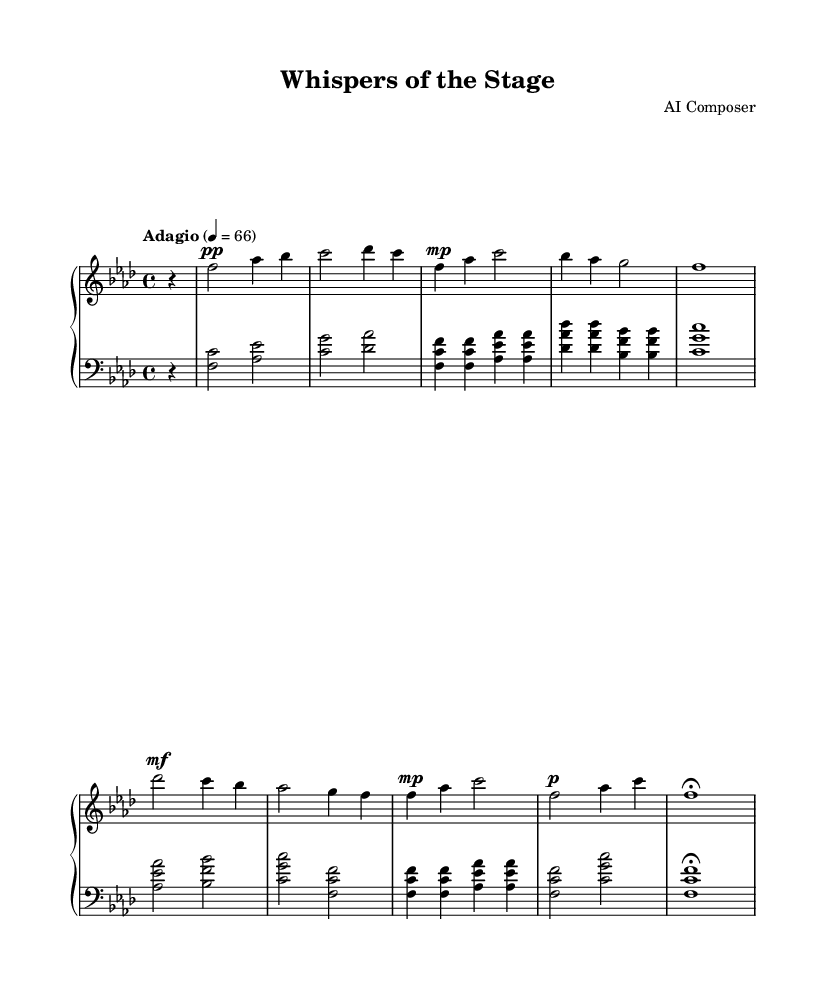What is the key signature of this music? The key signature is identified by looking at the beginning of the staff. There is a flat sign for B, E, and A. This indicates that the key is F minor, which has four flats (B, E, A, and D).
Answer: F minor What is the time signature of this music? The time signature is found at the start of the music, represented as two numbers. In this case, it appears as 4 over 4, indicating four beats per measure.
Answer: 4/4 What is the tempo marking for this piece? The tempo is usually indicated in Italian at the beginning of the score. Here it states "Adagio" followed by a metronome marking of 66, meaning it should be played slowly at this pace.
Answer: Adagio How many sections are in this piece? By analyzing the structure of the music, we can see distinct parts: an intro, a verse, a bridge, a repeated verse, and an outro. Counting these, we identify that there are five sections.
Answer: 5 What dynamic marking is used in the intro? The dynamic marking at the beginning of the piece is indicated with 'pp' which stands for pianissimo, meaning very soft. This indicates how the pianist should play during this section.
Answer: pianissimo What is the range of the upper staff? Looking at the notes in the upper staff, the lowest note starts from F and the highest reaches C. Observing the notes, we can deduce the range spans from F to C, roughly a perfect fourth apart.
Answer: F to C What is the last dynamic marking in this piece? The last dynamic marking appears in the outro section, where it indicates 'p', which stands for piano, meaning soft. The presence of 'fermata' indicates to hold the note, contributing to a soft ending.
Answer: piano 